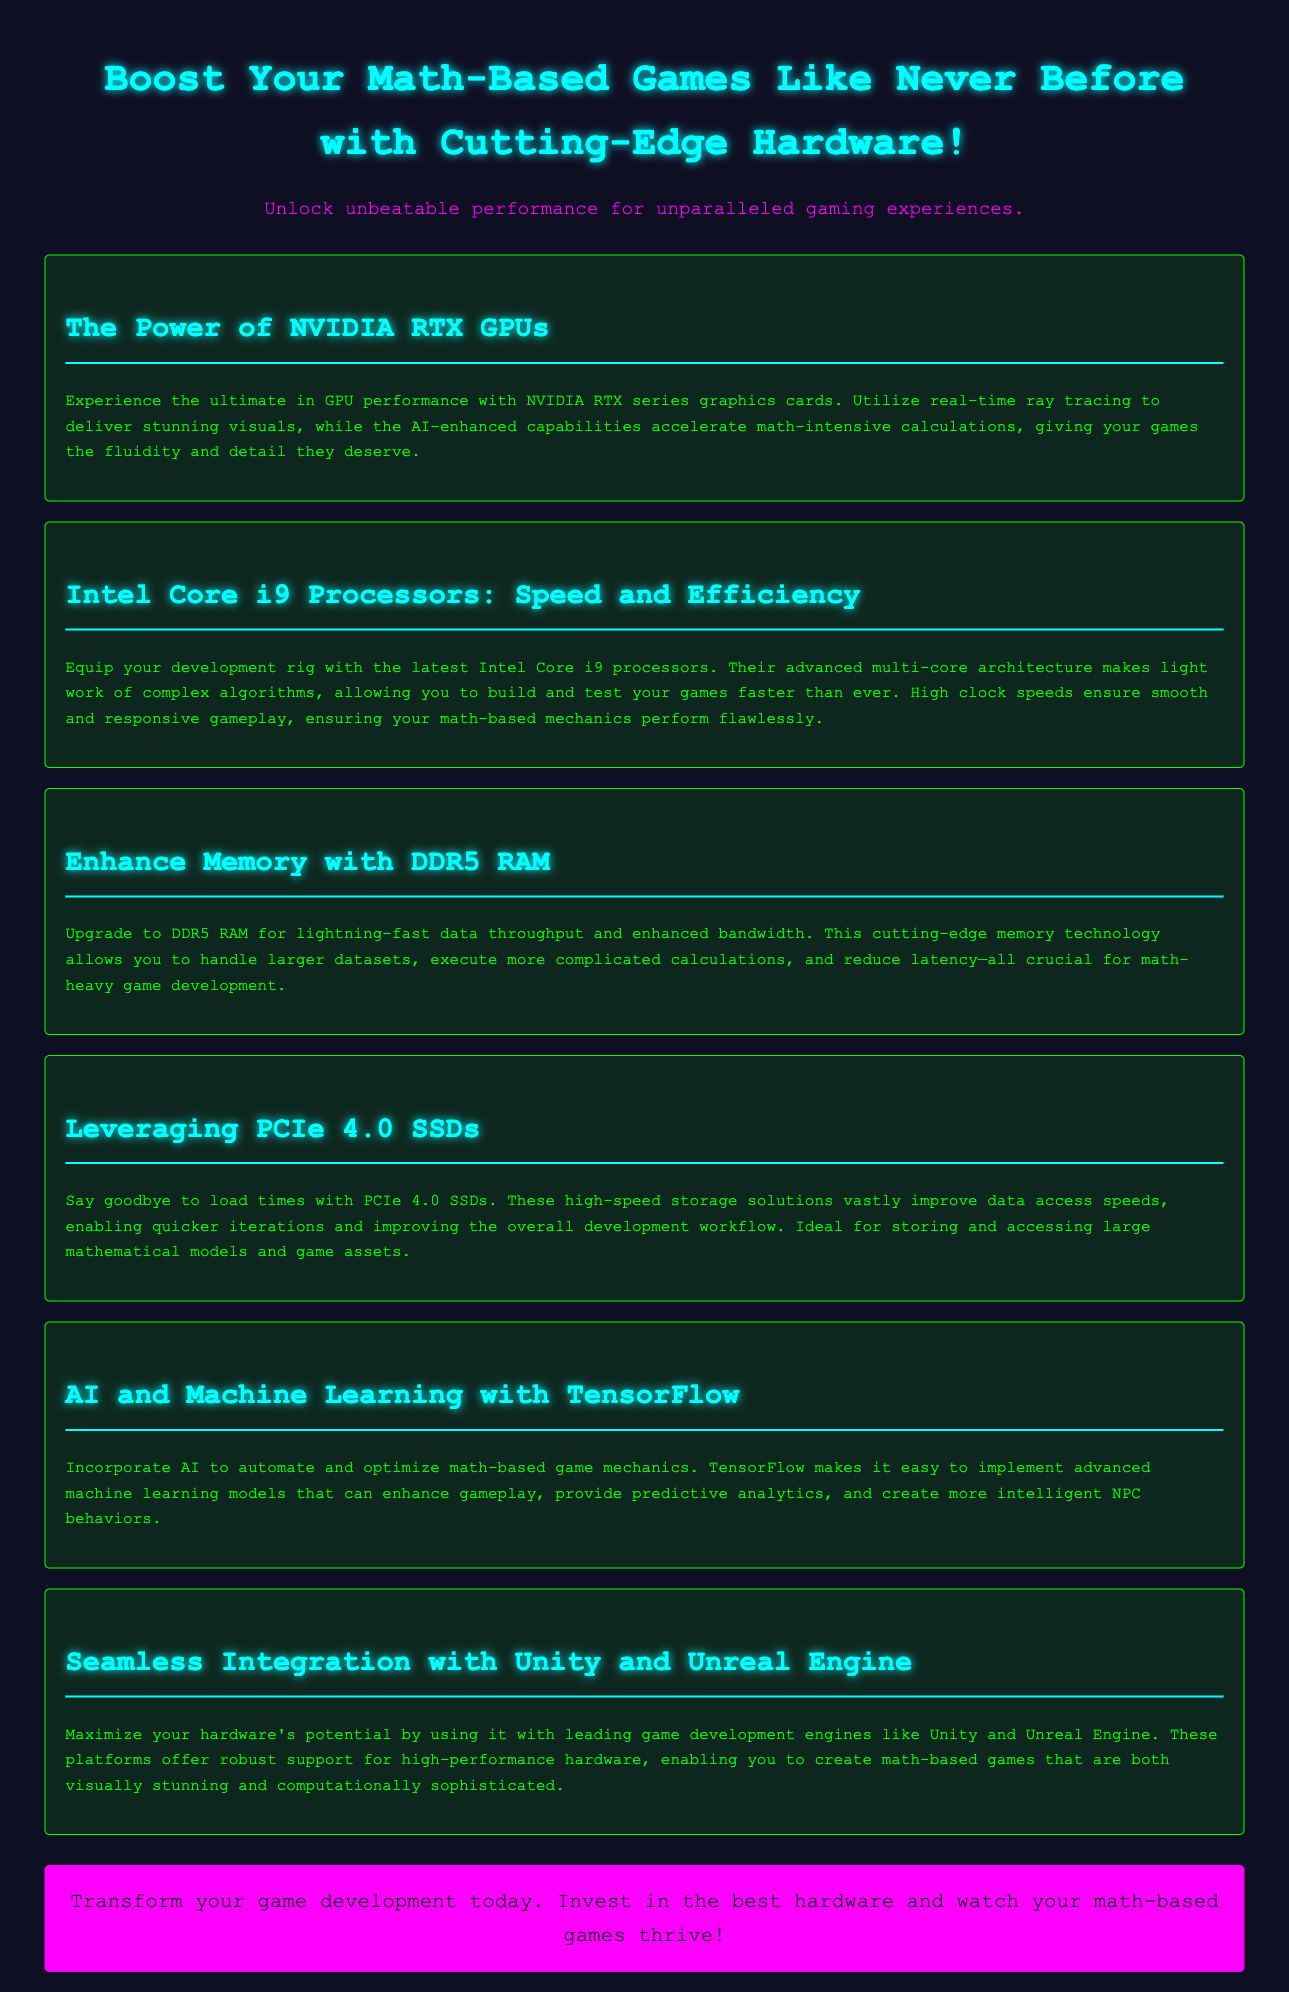What is the title of the advertisement? The title is prominently displayed at the top of the document, highlighting the purpose of the advertisement.
Answer: Boost Your Math-Based Games Which processor is mentioned as ideal for game development? The advertisement specifies the Intel Core i9 processors for their speed and efficiency in handling complex algorithms.
Answer: Intel Core i9 What type of RAM is recommended for enhancing memory? The document highlights DDR5 RAM as the cutting-edge memory technology essential for data throughput and bandwidth.
Answer: DDR5 RAM What technology is mentioned for automating game mechanics? The advertisement refers to TensorFlow in the context of incorporating AI and machine learning into game development.
Answer: TensorFlow Which SSD type is promoted in the document? The document emphasizes the benefits of PCIe 4.0 SSDs for improving data access speeds and reducing load times.
Answer: PCIe 4.0 SSDs What is one benefit of using NVIDIA RTX GPUs? The advertisement points out that NVIDIA RTX GPUs offer real-time ray tracing for stunning visuals in games.
Answer: Real-time ray tracing How does the document suggest improving the overall development workflow? The advertisement mentions using high-speed storage solutions to enable quicker iterations as a way to enhance the workflow.
Answer: PCIe 4.0 SSDs What game development engines are highlighted for seamless integration? The advertisement specifies Unity and Unreal Engine as preferred platforms for leveraging high-performance hardware.
Answer: Unity and Unreal Engine 